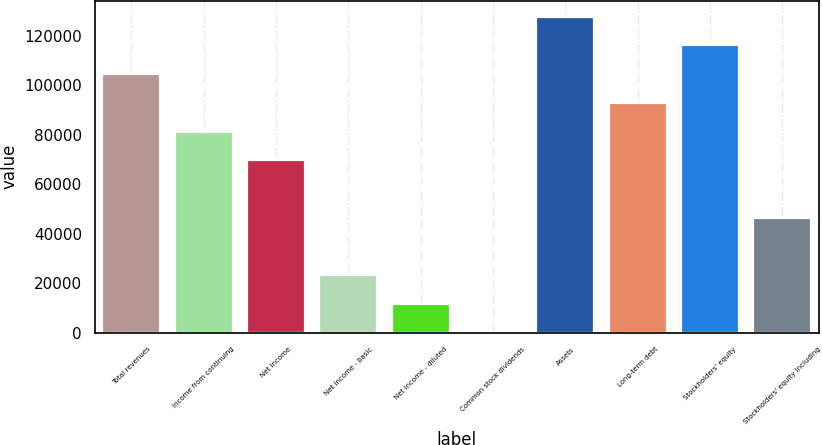<chart> <loc_0><loc_0><loc_500><loc_500><bar_chart><fcel>Total revenues<fcel>Income from continuing<fcel>Net income<fcel>Net income - basic<fcel>Net income - diluted<fcel>Common stock dividends<fcel>Assets<fcel>Long-term debt<fcel>Stockholders' equity<fcel>Stockholders' equity including<nl><fcel>104597<fcel>81353.7<fcel>69732<fcel>23244.9<fcel>11623.2<fcel>1.42<fcel>127841<fcel>92975.5<fcel>116219<fcel>46488.5<nl></chart> 